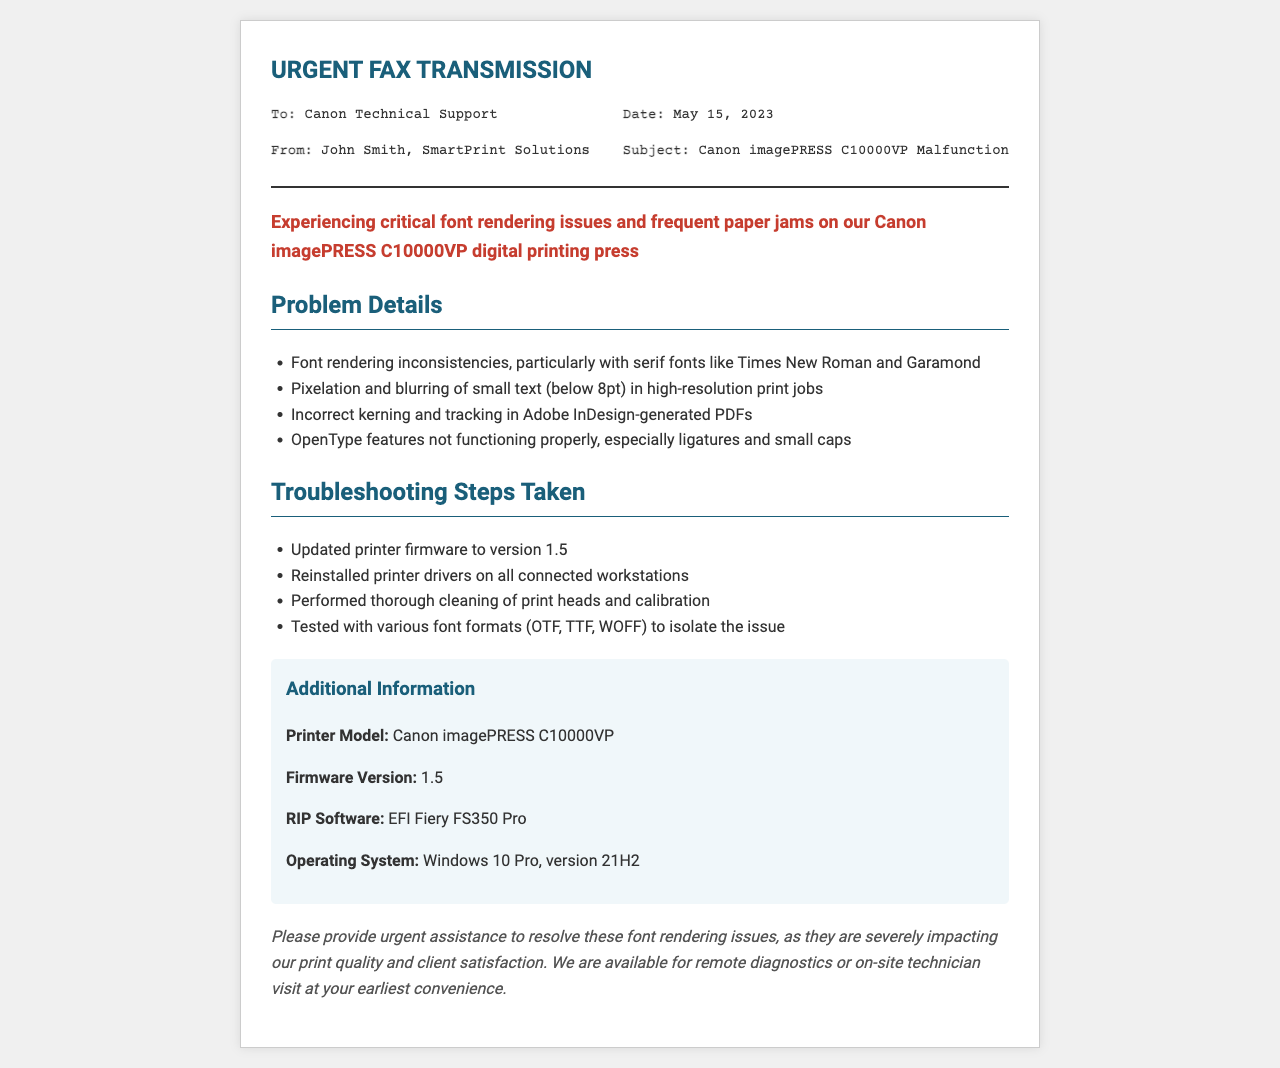What is the date of the fax? The date is included in the header details of the fax document, showing the specific day the fax was sent.
Answer: May 15, 2023 Who is the sender of the fax? The sender's information is listed under the "From" section in the header details of the fax.
Answer: John Smith, SmartPrint Solutions What printer model is experiencing issues? The printer model is stated in the additional information section of the document.
Answer: Canon imagePRESS C10000VP What firmware version is currently installed? The firmware version can be found in the additional information section of the fax.
Answer: 1.5 What are the font rendering inconsistencies related to? The specific font rendering issues highlighted in the problem details of the fax document are emphasized.
Answer: Serif fonts like Times New Roman and Garamond How many troubleshooting steps were taken? The number of troubleshooting steps can be determined by counting the items listed under the "Troubleshooting Steps Taken" section.
Answer: 4 What software is being used for RIP? The RIP software information is available in the additional information section of the fax document.
Answer: EFI Fiery FS350 Pro What is the primary purpose of this fax? The main purpose of the fax is conveyed in the request section at the end of the document.
Answer: Provide urgent assistance to resolve font rendering issues What operating system is mentioned? The operating system details are mentioned in the additional information section of the fax, specifying the exact version in use.
Answer: Windows 10 Pro, version 21H2 